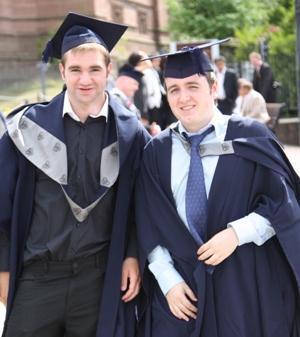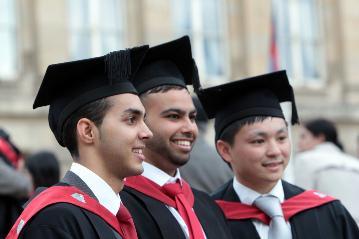The first image is the image on the left, the second image is the image on the right. Analyze the images presented: Is the assertion "A male is holding his diploma in the image on the right." valid? Answer yes or no. No. The first image is the image on the left, the second image is the image on the right. For the images shown, is this caption "The diplomas the people are holding have red ribbons around them." true? Answer yes or no. No. 